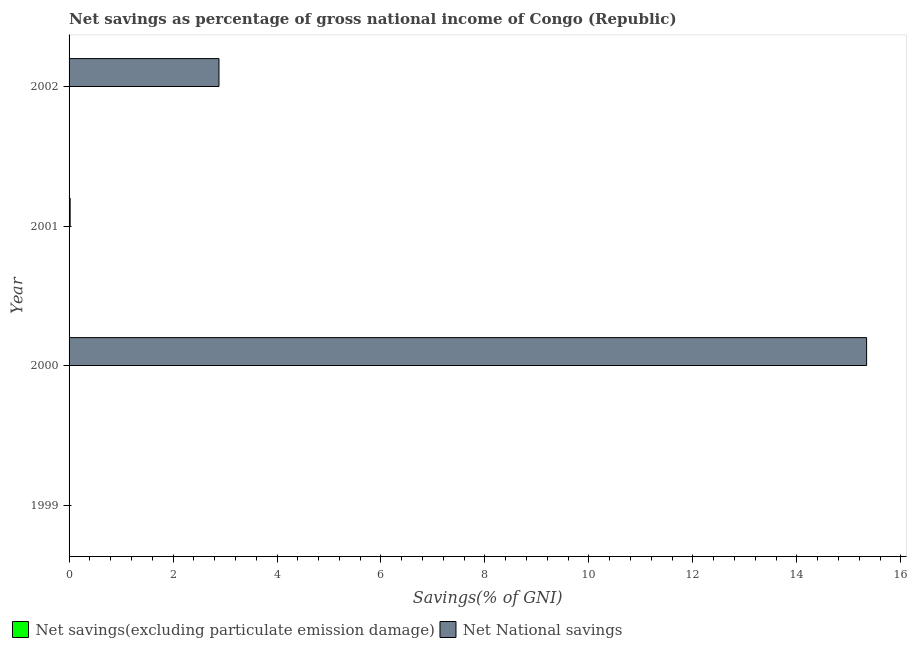Are the number of bars on each tick of the Y-axis equal?
Provide a short and direct response. No. How many bars are there on the 2nd tick from the top?
Provide a short and direct response. 1. How many bars are there on the 3rd tick from the bottom?
Offer a very short reply. 1. What is the label of the 2nd group of bars from the top?
Ensure brevity in your answer.  2001. In how many cases, is the number of bars for a given year not equal to the number of legend labels?
Give a very brief answer. 4. What is the net savings(excluding particulate emission damage) in 2001?
Your answer should be very brief. 0. Across all years, what is the maximum net national savings?
Provide a succinct answer. 15.34. What is the total net national savings in the graph?
Your response must be concise. 18.25. What is the difference between the net national savings in 2000 and that in 2001?
Your response must be concise. 15.32. What is the average net national savings per year?
Make the answer very short. 4.56. What is the ratio of the net national savings in 2000 to that in 2001?
Your answer should be compact. 740.37. Is the net national savings in 2000 less than that in 2001?
Offer a very short reply. No. What is the difference between the highest and the second highest net national savings?
Offer a very short reply. 12.46. What is the difference between the highest and the lowest net national savings?
Provide a succinct answer. 15.34. In how many years, is the net national savings greater than the average net national savings taken over all years?
Offer a very short reply. 1. How many bars are there?
Offer a very short reply. 3. What is the difference between two consecutive major ticks on the X-axis?
Your response must be concise. 2. Does the graph contain grids?
Provide a succinct answer. No. Where does the legend appear in the graph?
Provide a succinct answer. Bottom left. What is the title of the graph?
Ensure brevity in your answer.  Net savings as percentage of gross national income of Congo (Republic). What is the label or title of the X-axis?
Make the answer very short. Savings(% of GNI). What is the label or title of the Y-axis?
Offer a very short reply. Year. What is the Savings(% of GNI) in Net savings(excluding particulate emission damage) in 2000?
Keep it short and to the point. 0. What is the Savings(% of GNI) of Net National savings in 2000?
Offer a very short reply. 15.34. What is the Savings(% of GNI) of Net National savings in 2001?
Offer a very short reply. 0.02. What is the Savings(% of GNI) in Net National savings in 2002?
Provide a short and direct response. 2.88. Across all years, what is the maximum Savings(% of GNI) in Net National savings?
Offer a very short reply. 15.34. Across all years, what is the minimum Savings(% of GNI) of Net National savings?
Your answer should be compact. 0. What is the total Savings(% of GNI) of Net National savings in the graph?
Your answer should be compact. 18.25. What is the difference between the Savings(% of GNI) in Net National savings in 2000 and that in 2001?
Make the answer very short. 15.32. What is the difference between the Savings(% of GNI) in Net National savings in 2000 and that in 2002?
Your answer should be compact. 12.46. What is the difference between the Savings(% of GNI) of Net National savings in 2001 and that in 2002?
Provide a short and direct response. -2.86. What is the average Savings(% of GNI) in Net savings(excluding particulate emission damage) per year?
Provide a succinct answer. 0. What is the average Savings(% of GNI) of Net National savings per year?
Offer a terse response. 4.56. What is the ratio of the Savings(% of GNI) of Net National savings in 2000 to that in 2001?
Give a very brief answer. 740.37. What is the ratio of the Savings(% of GNI) in Net National savings in 2000 to that in 2002?
Provide a succinct answer. 5.32. What is the ratio of the Savings(% of GNI) of Net National savings in 2001 to that in 2002?
Make the answer very short. 0.01. What is the difference between the highest and the second highest Savings(% of GNI) of Net National savings?
Provide a succinct answer. 12.46. What is the difference between the highest and the lowest Savings(% of GNI) in Net National savings?
Make the answer very short. 15.34. 